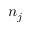Convert formula to latex. <formula><loc_0><loc_0><loc_500><loc_500>n _ { j }</formula> 